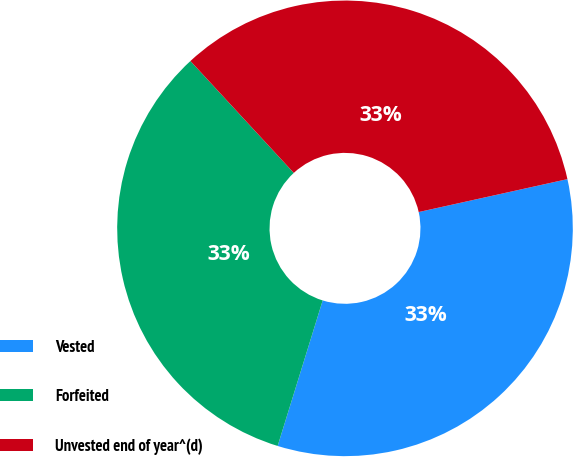Convert chart. <chart><loc_0><loc_0><loc_500><loc_500><pie_chart><fcel>Vested<fcel>Forfeited<fcel>Unvested end of year^(d)<nl><fcel>33.24%<fcel>33.35%<fcel>33.4%<nl></chart> 